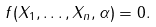<formula> <loc_0><loc_0><loc_500><loc_500>f ( X _ { 1 } , \dots , X _ { n } , \alpha ) = 0 .</formula> 